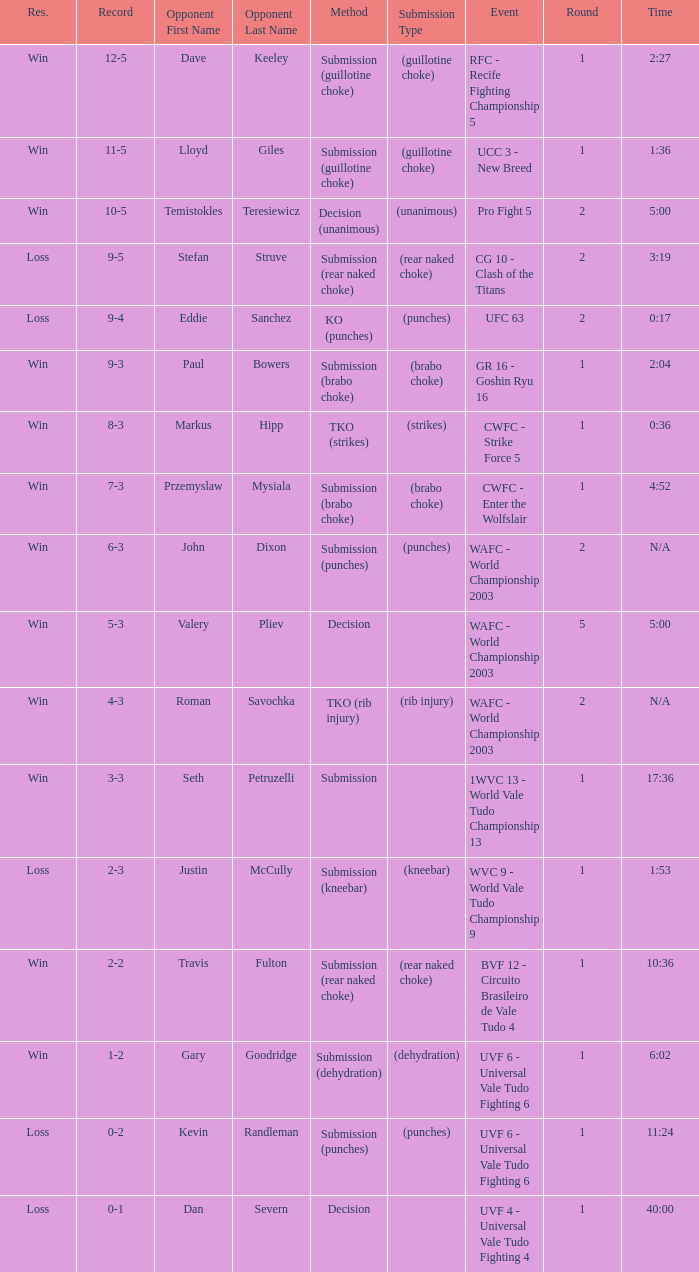Can you parse all the data within this table? {'header': ['Res.', 'Record', 'Opponent First Name', 'Opponent Last Name', 'Method', 'Submission Type', 'Event', 'Round', 'Time'], 'rows': [['Win', '12-5', 'Dave', 'Keeley', 'Submission (guillotine choke)', '(guillotine choke)', 'RFC - Recife Fighting Championship 5', '1', '2:27'], ['Win', '11-5', 'Lloyd', 'Giles', 'Submission (guillotine choke)', '(guillotine choke)', 'UCC 3 - New Breed', '1', '1:36'], ['Win', '10-5', 'Temistokles', 'Teresiewicz', 'Decision (unanimous)', '(unanimous)', 'Pro Fight 5', '2', '5:00'], ['Loss', '9-5', 'Stefan', 'Struve', 'Submission (rear naked choke)', '(rear naked choke)', 'CG 10 - Clash of the Titans', '2', '3:19'], ['Loss', '9-4', 'Eddie', 'Sanchez', 'KO (punches)', '(punches)', 'UFC 63', '2', '0:17'], ['Win', '9-3', 'Paul', 'Bowers', 'Submission (brabo choke)', '(brabo choke)', 'GR 16 - Goshin Ryu 16', '1', '2:04'], ['Win', '8-3', 'Markus', 'Hipp', 'TKO (strikes)', '(strikes)', 'CWFC - Strike Force 5', '1', '0:36'], ['Win', '7-3', 'Przemyslaw', 'Mysiala', 'Submission (brabo choke)', '(brabo choke)', 'CWFC - Enter the Wolfslair', '1', '4:52'], ['Win', '6-3', 'John', 'Dixon', 'Submission (punches)', '(punches)', 'WAFC - World Championship 2003', '2', 'N/A'], ['Win', '5-3', 'Valery', 'Pliev', 'Decision', '', 'WAFC - World Championship 2003', '5', '5:00'], ['Win', '4-3', 'Roman', 'Savochka', 'TKO (rib injury)', '(rib injury)', 'WAFC - World Championship 2003', '2', 'N/A'], ['Win', '3-3', 'Seth', 'Petruzelli', 'Submission', '', '1WVC 13 - World Vale Tudo Championship 13', '1', '17:36'], ['Loss', '2-3', 'Justin', 'McCully', 'Submission (kneebar)', '(kneebar)', 'WVC 9 - World Vale Tudo Championship 9', '1', '1:53'], ['Win', '2-2', 'Travis', 'Fulton', 'Submission (rear naked choke)', '(rear naked choke)', 'BVF 12 - Circuito Brasileiro de Vale Tudo 4', '1', '10:36'], ['Win', '1-2', 'Gary', 'Goodridge', 'Submission (dehydration)', '(dehydration)', 'UVF 6 - Universal Vale Tudo Fighting 6', '1', '6:02'], ['Loss', '0-2', 'Kevin', 'Randleman', 'Submission (punches)', '(punches)', 'UVF 6 - Universal Vale Tudo Fighting 6', '1', '11:24'], ['Loss', '0-1', 'Dan', 'Severn', 'Decision', '', 'UVF 4 - Universal Vale Tudo Fighting 4', '1', '40:00']]} What round has the highest Res loss, and a time of 40:00? 1.0. 